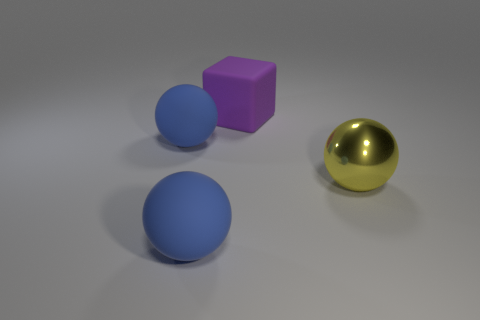In what kind of environment do you think this image was taken? This image appears to be a rendered scene rather than a photograph taken in a physical environment. The uniform background and soft shadows suggest it may have been created in a digital 3D modeling program, designed to showcase the objects with neutral lighting and minimal distraction. 